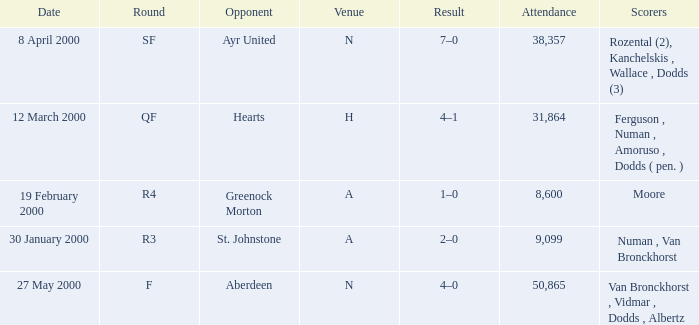Who was on 12 March 2000? Ferguson , Numan , Amoruso , Dodds ( pen. ). 